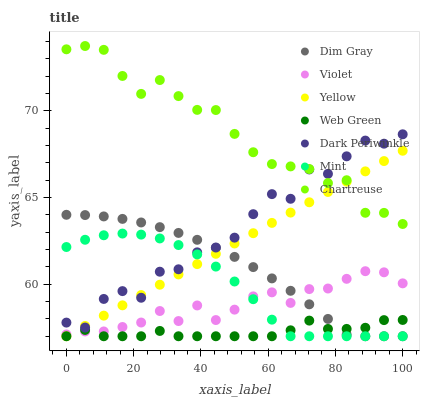Does Web Green have the minimum area under the curve?
Answer yes or no. Yes. Does Chartreuse have the maximum area under the curve?
Answer yes or no. Yes. Does Chartreuse have the minimum area under the curve?
Answer yes or no. No. Does Web Green have the maximum area under the curve?
Answer yes or no. No. Is Yellow the smoothest?
Answer yes or no. Yes. Is Dark Periwinkle the roughest?
Answer yes or no. Yes. Is Web Green the smoothest?
Answer yes or no. No. Is Web Green the roughest?
Answer yes or no. No. Does Dim Gray have the lowest value?
Answer yes or no. Yes. Does Chartreuse have the lowest value?
Answer yes or no. No. Does Chartreuse have the highest value?
Answer yes or no. Yes. Does Web Green have the highest value?
Answer yes or no. No. Is Violet less than Chartreuse?
Answer yes or no. Yes. Is Chartreuse greater than Violet?
Answer yes or no. Yes. Does Web Green intersect Yellow?
Answer yes or no. Yes. Is Web Green less than Yellow?
Answer yes or no. No. Is Web Green greater than Yellow?
Answer yes or no. No. Does Violet intersect Chartreuse?
Answer yes or no. No. 